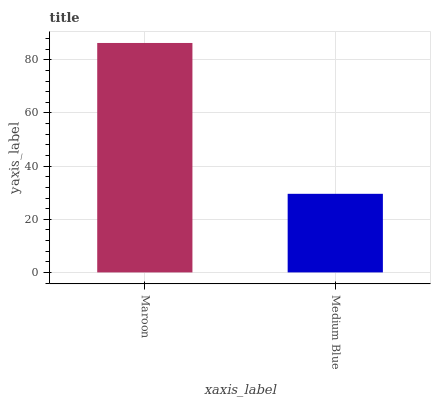Is Medium Blue the minimum?
Answer yes or no. Yes. Is Maroon the maximum?
Answer yes or no. Yes. Is Medium Blue the maximum?
Answer yes or no. No. Is Maroon greater than Medium Blue?
Answer yes or no. Yes. Is Medium Blue less than Maroon?
Answer yes or no. Yes. Is Medium Blue greater than Maroon?
Answer yes or no. No. Is Maroon less than Medium Blue?
Answer yes or no. No. Is Maroon the high median?
Answer yes or no. Yes. Is Medium Blue the low median?
Answer yes or no. Yes. Is Medium Blue the high median?
Answer yes or no. No. Is Maroon the low median?
Answer yes or no. No. 